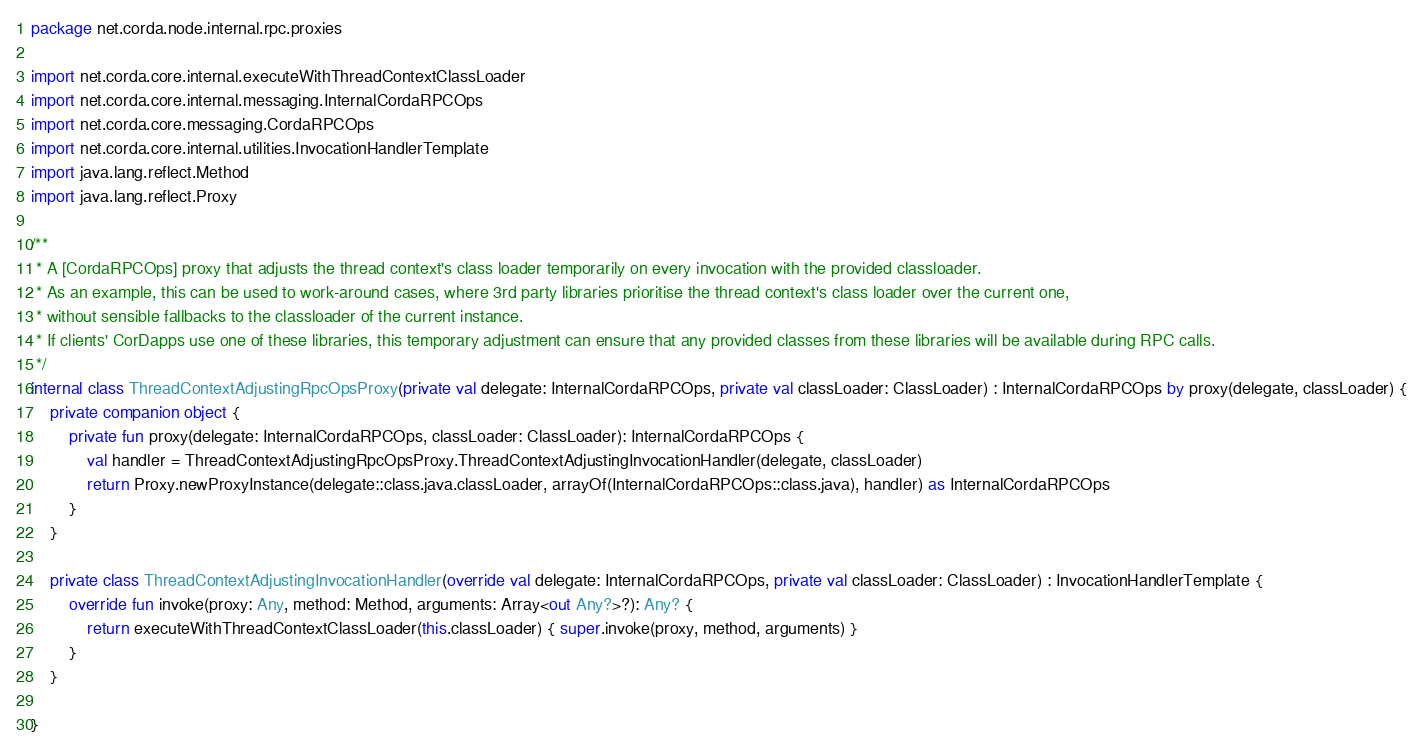Convert code to text. <code><loc_0><loc_0><loc_500><loc_500><_Kotlin_>package net.corda.node.internal.rpc.proxies

import net.corda.core.internal.executeWithThreadContextClassLoader
import net.corda.core.internal.messaging.InternalCordaRPCOps
import net.corda.core.messaging.CordaRPCOps
import net.corda.core.internal.utilities.InvocationHandlerTemplate
import java.lang.reflect.Method
import java.lang.reflect.Proxy

/**
 * A [CordaRPCOps] proxy that adjusts the thread context's class loader temporarily on every invocation with the provided classloader.
 * As an example, this can be used to work-around cases, where 3rd party libraries prioritise the thread context's class loader over the current one,
 * without sensible fallbacks to the classloader of the current instance.
 * If clients' CorDapps use one of these libraries, this temporary adjustment can ensure that any provided classes from these libraries will be available during RPC calls.
 */
internal class ThreadContextAdjustingRpcOpsProxy(private val delegate: InternalCordaRPCOps, private val classLoader: ClassLoader) : InternalCordaRPCOps by proxy(delegate, classLoader) {
    private companion object {
        private fun proxy(delegate: InternalCordaRPCOps, classLoader: ClassLoader): InternalCordaRPCOps {
            val handler = ThreadContextAdjustingRpcOpsProxy.ThreadContextAdjustingInvocationHandler(delegate, classLoader)
            return Proxy.newProxyInstance(delegate::class.java.classLoader, arrayOf(InternalCordaRPCOps::class.java), handler) as InternalCordaRPCOps
        }
    }

    private class ThreadContextAdjustingInvocationHandler(override val delegate: InternalCordaRPCOps, private val classLoader: ClassLoader) : InvocationHandlerTemplate {
        override fun invoke(proxy: Any, method: Method, arguments: Array<out Any?>?): Any? {
            return executeWithThreadContextClassLoader(this.classLoader) { super.invoke(proxy, method, arguments) }
        }
    }

}</code> 